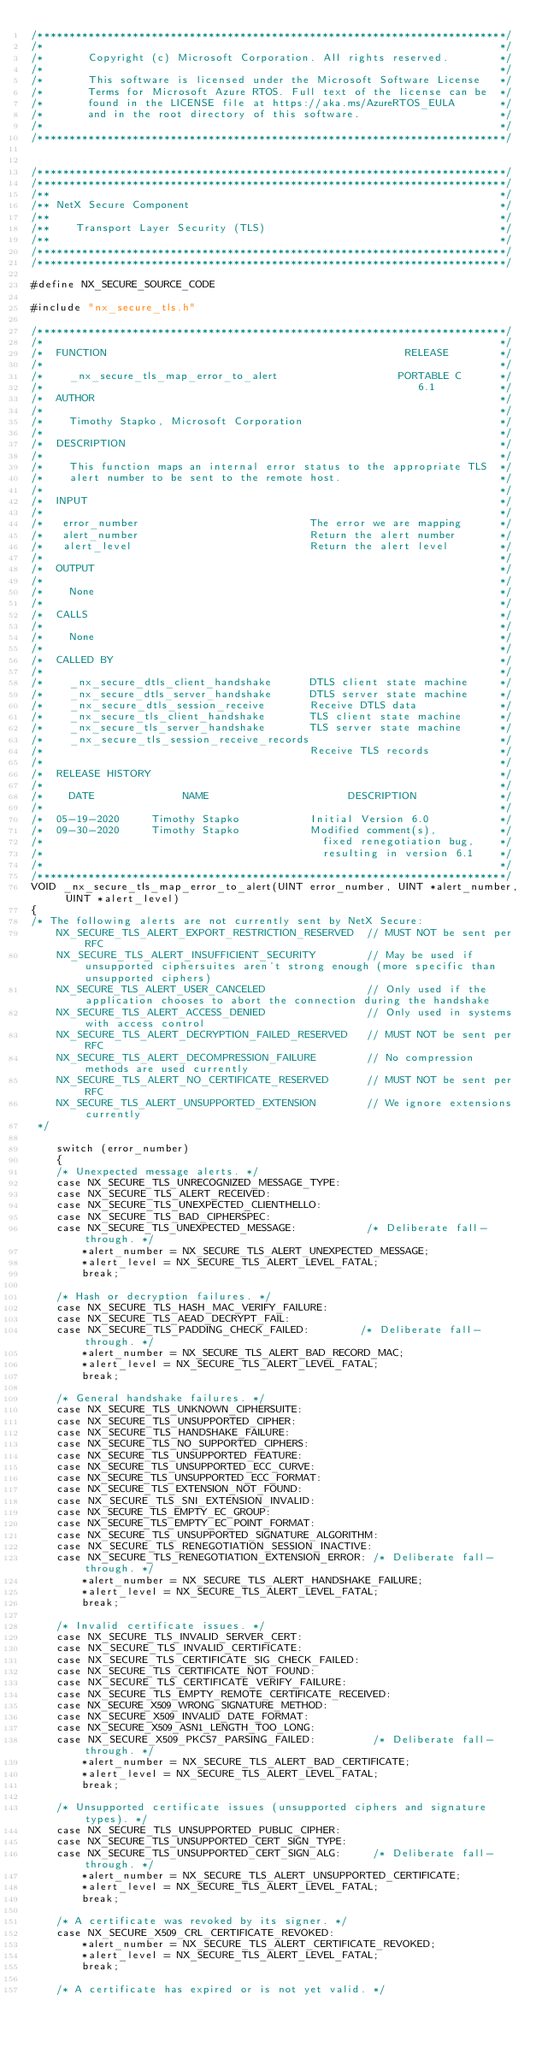<code> <loc_0><loc_0><loc_500><loc_500><_C_>/**************************************************************************/
/*                                                                        */
/*       Copyright (c) Microsoft Corporation. All rights reserved.        */
/*                                                                        */
/*       This software is licensed under the Microsoft Software License   */
/*       Terms for Microsoft Azure RTOS. Full text of the license can be  */
/*       found in the LICENSE file at https://aka.ms/AzureRTOS_EULA       */
/*       and in the root directory of this software.                      */
/*                                                                        */
/**************************************************************************/


/**************************************************************************/
/**************************************************************************/
/**                                                                       */
/** NetX Secure Component                                                 */
/**                                                                       */
/**    Transport Layer Security (TLS)                                     */
/**                                                                       */
/**************************************************************************/
/**************************************************************************/

#define NX_SECURE_SOURCE_CODE

#include "nx_secure_tls.h"

/**************************************************************************/
/*                                                                        */
/*  FUNCTION                                               RELEASE        */
/*                                                                        */
/*    _nx_secure_tls_map_error_to_alert                   PORTABLE C      */
/*                                                           6.1          */
/*  AUTHOR                                                                */
/*                                                                        */
/*    Timothy Stapko, Microsoft Corporation                               */
/*                                                                        */
/*  DESCRIPTION                                                           */
/*                                                                        */
/*    This function maps an internal error status to the appropriate TLS  */
/*    alert number to be sent to the remote host.                         */
/*                                                                        */
/*  INPUT                                                                 */
/*                                                                        */
/*   error_number                           The error we are mapping      */
/*   alert_number                           Return the alert number       */
/*   alert_level                            Return the alert level        */
/*                                                                        */
/*  OUTPUT                                                                */
/*                                                                        */
/*    None                                                                */
/*                                                                        */
/*  CALLS                                                                 */
/*                                                                        */
/*    None                                                                */
/*                                                                        */
/*  CALLED BY                                                             */
/*                                                                        */
/*    _nx_secure_dtls_client_handshake      DTLS client state machine     */
/*    _nx_secure_dtls_server_handshake      DTLS server state machine     */
/*    _nx_secure_dtls_session_receive       Receive DTLS data             */
/*    _nx_secure_tls_client_handshake       TLS client state machine      */
/*    _nx_secure_tls_server_handshake       TLS server state machine      */
/*    _nx_secure_tls_session_receive_records                              */
/*                                          Receive TLS records           */
/*                                                                        */
/*  RELEASE HISTORY                                                       */
/*                                                                        */
/*    DATE              NAME                      DESCRIPTION             */
/*                                                                        */
/*  05-19-2020     Timothy Stapko           Initial Version 6.0           */
/*  09-30-2020     Timothy Stapko           Modified comment(s),          */
/*                                            fixed renegotiation bug,    */
/*                                            resulting in version 6.1    */
/*                                                                        */
/**************************************************************************/
VOID _nx_secure_tls_map_error_to_alert(UINT error_number, UINT *alert_number, UINT *alert_level)
{
/* The following alerts are not currently sent by NetX Secure:
    NX_SECURE_TLS_ALERT_EXPORT_RESTRICTION_RESERVED  // MUST NOT be sent per RFC
    NX_SECURE_TLS_ALERT_INSUFFICIENT_SECURITY        // May be used if unsupported ciphersuites aren't strong enough (more specific than unsupported ciphers)
    NX_SECURE_TLS_ALERT_USER_CANCELED                // Only used if the application chooses to abort the connection during the handshake
    NX_SECURE_TLS_ALERT_ACCESS_DENIED                // Only used in systems with access control
    NX_SECURE_TLS_ALERT_DECRYPTION_FAILED_RESERVED   // MUST NOT be sent per RFC
    NX_SECURE_TLS_ALERT_DECOMPRESSION_FAILURE        // No compression methods are used currently
    NX_SECURE_TLS_ALERT_NO_CERTIFICATE_RESERVED      // MUST NOT be sent per RFC
    NX_SECURE_TLS_ALERT_UNSUPPORTED_EXTENSION        // We ignore extensions currently
 */

    switch (error_number)
    {
    /* Unexpected message alerts. */
    case NX_SECURE_TLS_UNRECOGNIZED_MESSAGE_TYPE:
    case NX_SECURE_TLS_ALERT_RECEIVED:
    case NX_SECURE_TLS_UNEXPECTED_CLIENTHELLO:
    case NX_SECURE_TLS_BAD_CIPHERSPEC:               
    case NX_SECURE_TLS_UNEXPECTED_MESSAGE:           /* Deliberate fall-through. */
        *alert_number = NX_SECURE_TLS_ALERT_UNEXPECTED_MESSAGE;
        *alert_level = NX_SECURE_TLS_ALERT_LEVEL_FATAL;
        break;

    /* Hash or decryption failures. */
    case NX_SECURE_TLS_HASH_MAC_VERIFY_FAILURE:
    case NX_SECURE_TLS_AEAD_DECRYPT_FAIL:
    case NX_SECURE_TLS_PADDING_CHECK_FAILED:        /* Deliberate fall-through. */
        *alert_number = NX_SECURE_TLS_ALERT_BAD_RECORD_MAC;
        *alert_level = NX_SECURE_TLS_ALERT_LEVEL_FATAL;
        break;

    /* General handshake failures. */
    case NX_SECURE_TLS_UNKNOWN_CIPHERSUITE:
    case NX_SECURE_TLS_UNSUPPORTED_CIPHER:
    case NX_SECURE_TLS_HANDSHAKE_FAILURE:
    case NX_SECURE_TLS_NO_SUPPORTED_CIPHERS:   
    case NX_SECURE_TLS_UNSUPPORTED_FEATURE:    
    case NX_SECURE_TLS_UNSUPPORTED_ECC_CURVE:
    case NX_SECURE_TLS_UNSUPPORTED_ECC_FORMAT:
    case NX_SECURE_TLS_EXTENSION_NOT_FOUND:
    case NX_SECURE_TLS_SNI_EXTENSION_INVALID:
    case NX_SECURE_TLS_EMPTY_EC_GROUP:
    case NX_SECURE_TLS_EMPTY_EC_POINT_FORMAT:
    case NX_SECURE_TLS_UNSUPPORTED_SIGNATURE_ALGORITHM:
    case NX_SECURE_TLS_RENEGOTIATION_SESSION_INACTIVE:
    case NX_SECURE_TLS_RENEGOTIATION_EXTENSION_ERROR: /* Deliberate fall-through. */
        *alert_number = NX_SECURE_TLS_ALERT_HANDSHAKE_FAILURE;
        *alert_level = NX_SECURE_TLS_ALERT_LEVEL_FATAL;
        break;

    /* Invalid certificate issues. */
    case NX_SECURE_TLS_INVALID_SERVER_CERT:
    case NX_SECURE_TLS_INVALID_CERTIFICATE:
    case NX_SECURE_TLS_CERTIFICATE_SIG_CHECK_FAILED:
    case NX_SECURE_TLS_CERTIFICATE_NOT_FOUND:
    case NX_SECURE_TLS_CERTIFICATE_VERIFY_FAILURE:
    case NX_SECURE_TLS_EMPTY_REMOTE_CERTIFICATE_RECEIVED:
    case NX_SECURE_X509_WRONG_SIGNATURE_METHOD:
    case NX_SECURE_X509_INVALID_DATE_FORMAT:
    case NX_SECURE_X509_ASN1_LENGTH_TOO_LONG:
    case NX_SECURE_X509_PKCS7_PARSING_FAILED:         /* Deliberate fall-through. */
        *alert_number = NX_SECURE_TLS_ALERT_BAD_CERTIFICATE;
        *alert_level = NX_SECURE_TLS_ALERT_LEVEL_FATAL;
        break;

    /* Unsupported certificate issues (unsupported ciphers and signature types). */
    case NX_SECURE_TLS_UNSUPPORTED_PUBLIC_CIPHER:
    case NX_SECURE_TLS_UNSUPPORTED_CERT_SIGN_TYPE:
    case NX_SECURE_TLS_UNSUPPORTED_CERT_SIGN_ALG:     /* Deliberate fall-through. */
        *alert_number = NX_SECURE_TLS_ALERT_UNSUPPORTED_CERTIFICATE;
        *alert_level = NX_SECURE_TLS_ALERT_LEVEL_FATAL;
        break;

    /* A certificate was revoked by its signer. */
    case NX_SECURE_X509_CRL_CERTIFICATE_REVOKED:
        *alert_number = NX_SECURE_TLS_ALERT_CERTIFICATE_REVOKED;
        *alert_level = NX_SECURE_TLS_ALERT_LEVEL_FATAL;
        break;

    /* A certificate has expired or is not yet valid. */</code> 